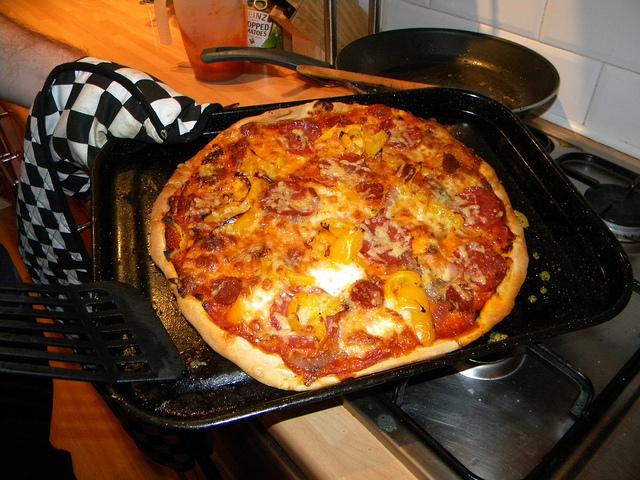What is the cooked food item?
Write a very short answer. Pizza. What ingredients might be used in this food item?
Concise answer only. Cheese, flour, tomato sauce. Would there have been room in the pan if the pizza were wider?
Concise answer only. No. 